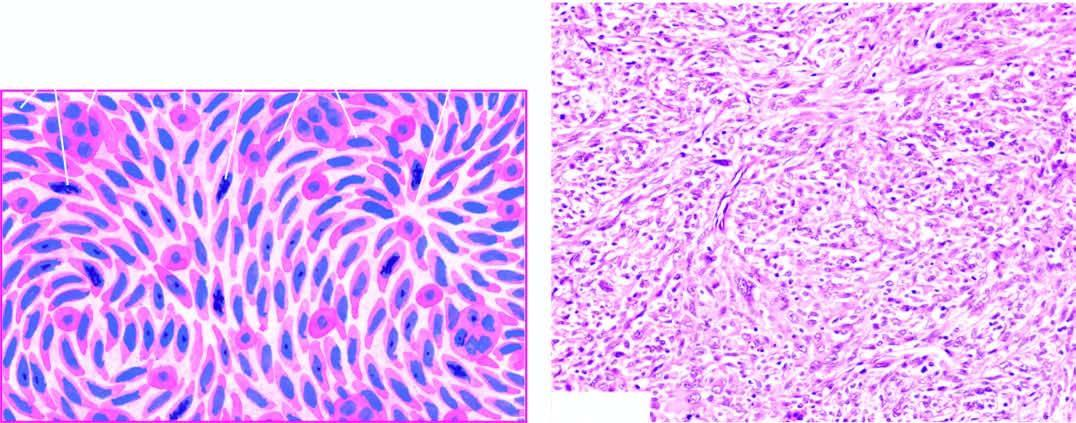does ziehl-neelsen show admixture of spindle-shaped pleomorphic cells forming storiform pattern and histiocyte-like round to oval cells?
Answer the question using a single word or phrase. No 